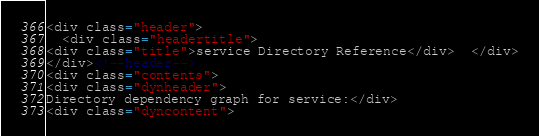<code> <loc_0><loc_0><loc_500><loc_500><_HTML_>
<div class="header">
  <div class="headertitle">
<div class="title">service Directory Reference</div>  </div>
</div><!--header-->
<div class="contents">
<div class="dynheader">
Directory dependency graph for service:</div>
<div class="dyncontent"></code> 